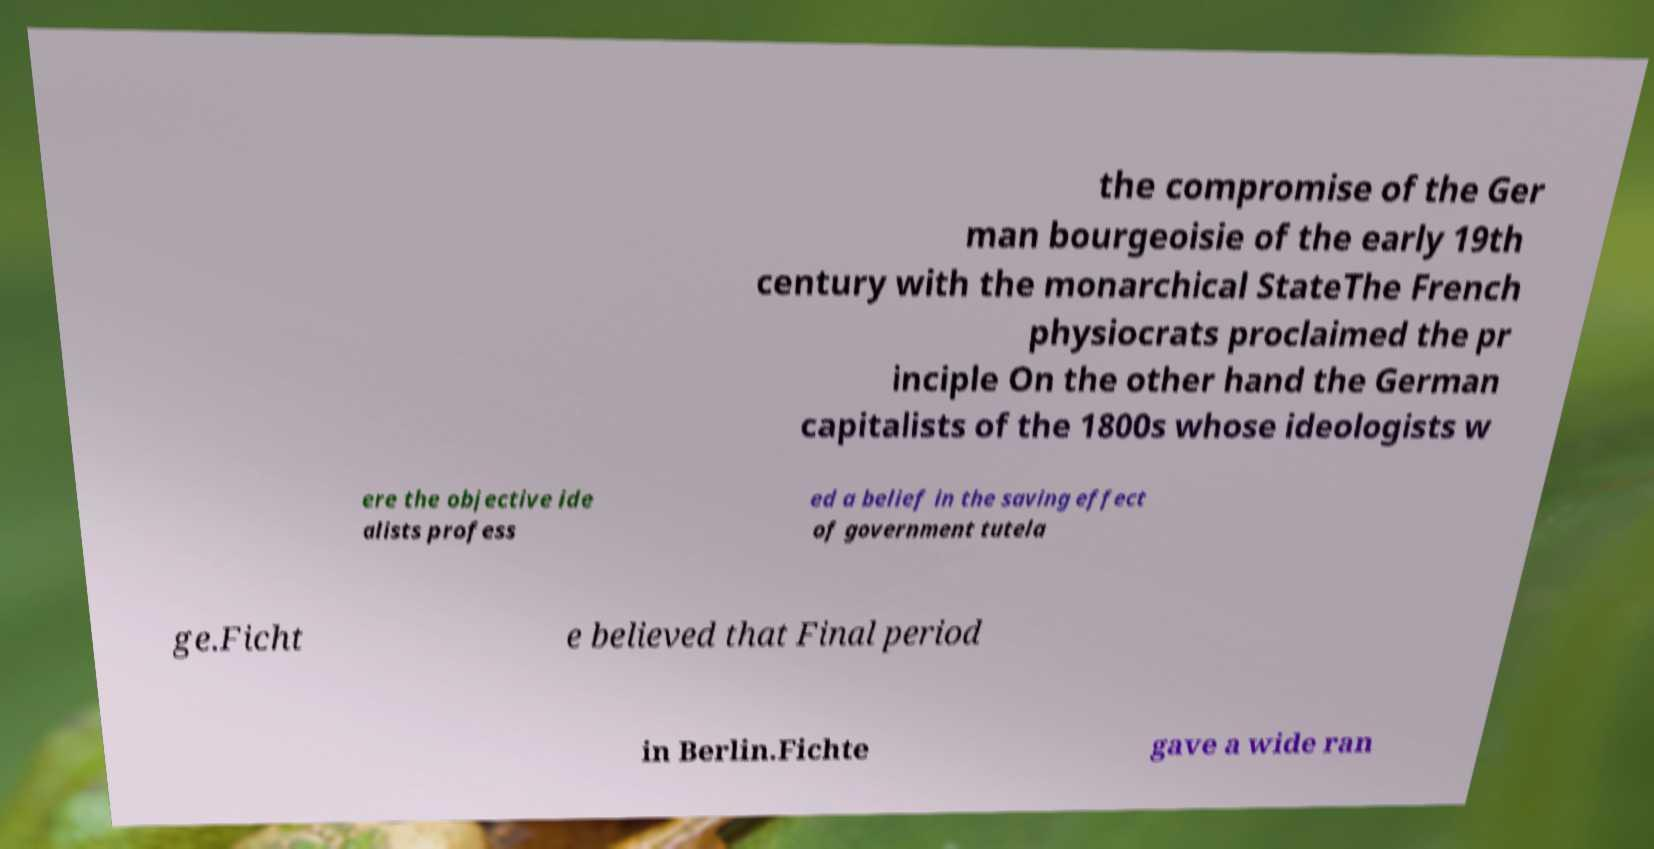What messages or text are displayed in this image? I need them in a readable, typed format. the compromise of the Ger man bourgeoisie of the early 19th century with the monarchical StateThe French physiocrats proclaimed the pr inciple On the other hand the German capitalists of the 1800s whose ideologists w ere the objective ide alists profess ed a belief in the saving effect of government tutela ge.Ficht e believed that Final period in Berlin.Fichte gave a wide ran 